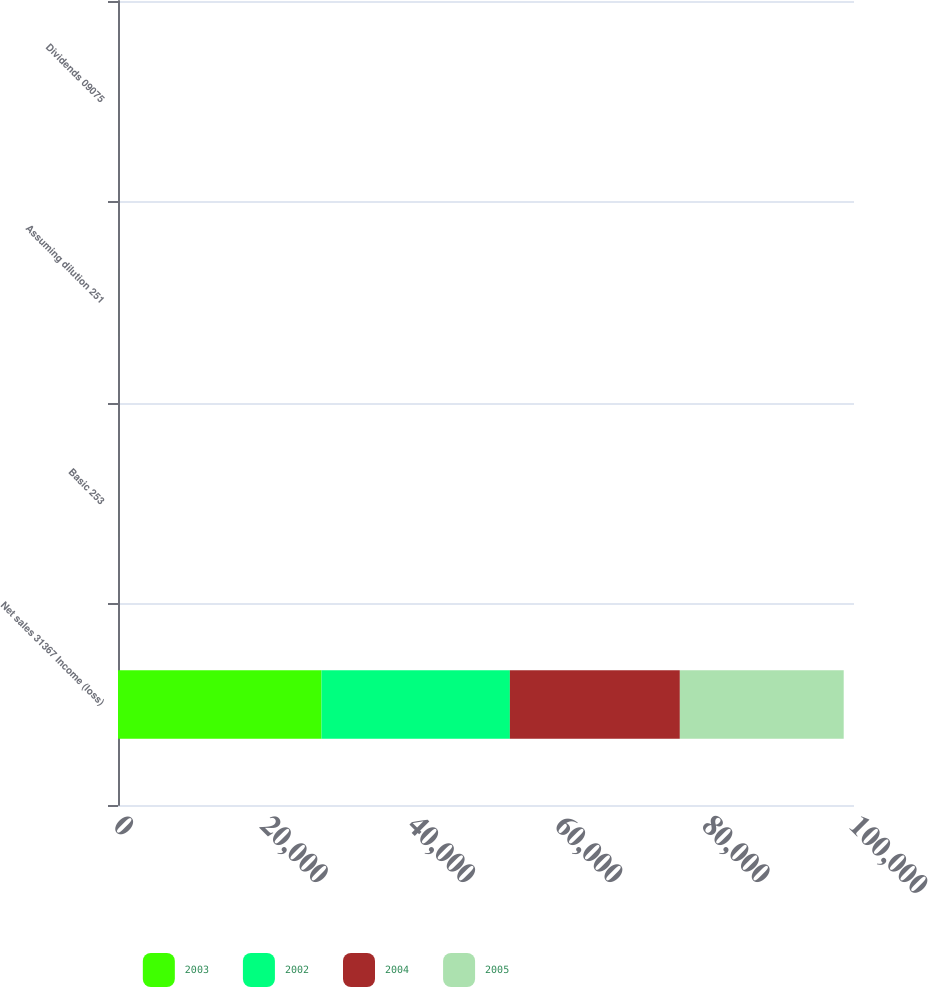Convert chart. <chart><loc_0><loc_0><loc_500><loc_500><stacked_bar_chart><ecel><fcel>Net sales 31367 Income (loss)<fcel>Basic 253<fcel>Assuming dilution 251<fcel>Dividends 09075<nl><fcel>2003<fcel>27652<fcel>1.85<fcel>1.84<fcel>0.82<nl><fcel>2002<fcel>25593<fcel>1.45<fcel>1.45<fcel>0.75<nl><fcel>2004<fcel>23095<fcel>1.52<fcel>1.52<fcel>0.75<nl><fcel>2005<fcel>22261<fcel>0.31<fcel>0.31<fcel>0.75<nl></chart> 